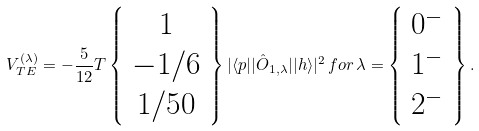<formula> <loc_0><loc_0><loc_500><loc_500>V ^ { ( \lambda ) } _ { T E } = - \frac { 5 } { 1 2 } T \left \{ \begin{array} { c } 1 \\ - 1 / 6 \\ 1 / 5 0 \end{array} \right \} | \langle p | | \hat { O } _ { 1 , \lambda } | | h \rangle | ^ { 2 } \, f o r \, \lambda = \left \{ \begin{array} { c } 0 ^ { - } \\ 1 ^ { - } \\ 2 ^ { - } \end{array} \right \} .</formula> 